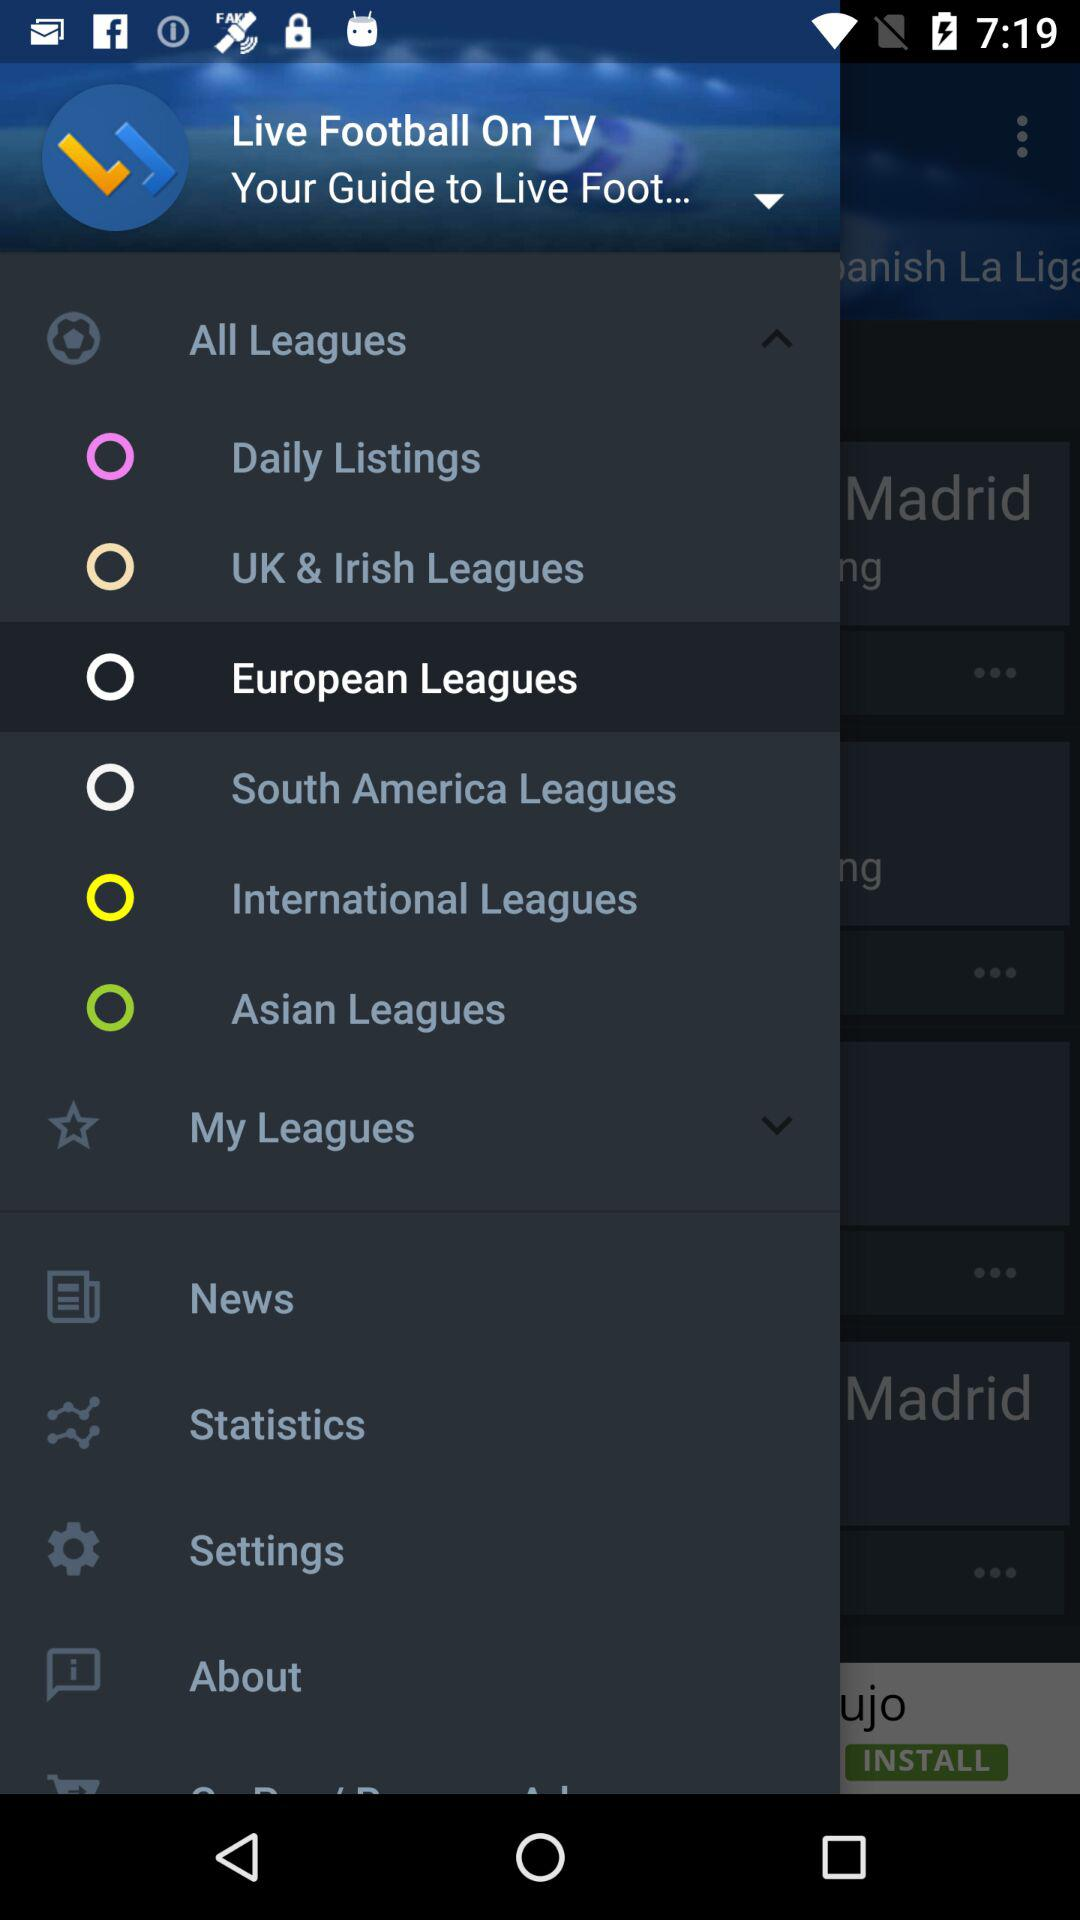What is the app name? The app name is "Live Football On TV". 